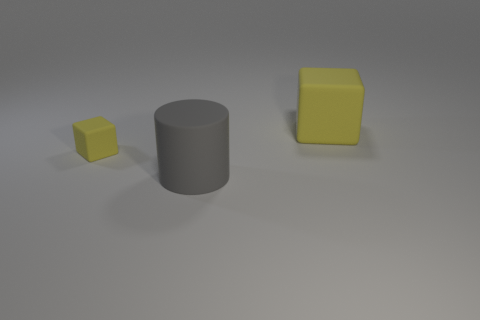Add 3 matte things. How many objects exist? 6 Subtract all blocks. How many objects are left? 1 Add 3 tiny brown metal objects. How many tiny brown metal objects exist? 3 Subtract 0 cyan cylinders. How many objects are left? 3 Subtract all large gray matte objects. Subtract all gray things. How many objects are left? 1 Add 2 yellow matte blocks. How many yellow matte blocks are left? 4 